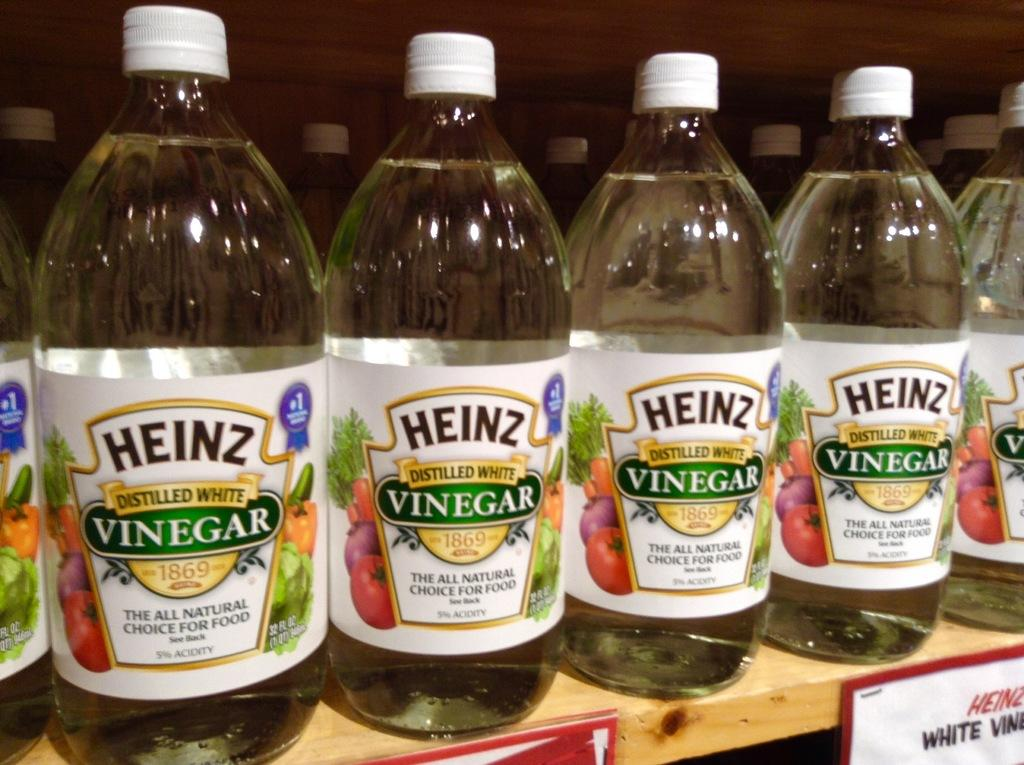What is contained in the glass bottles in the image? There is a liquid in the glass bottles in the image. How are the glass bottles arranged or supported in the image? The glass bottles are in a wooden rack in the image. What other object can be seen in the image besides the glass bottles? There is a board in the image. Can you describe the harmony of the stitches on the board in the image? There are no stitches or boards with stitches present in the image; it only features glass bottles with liquid in a wooden rack. 